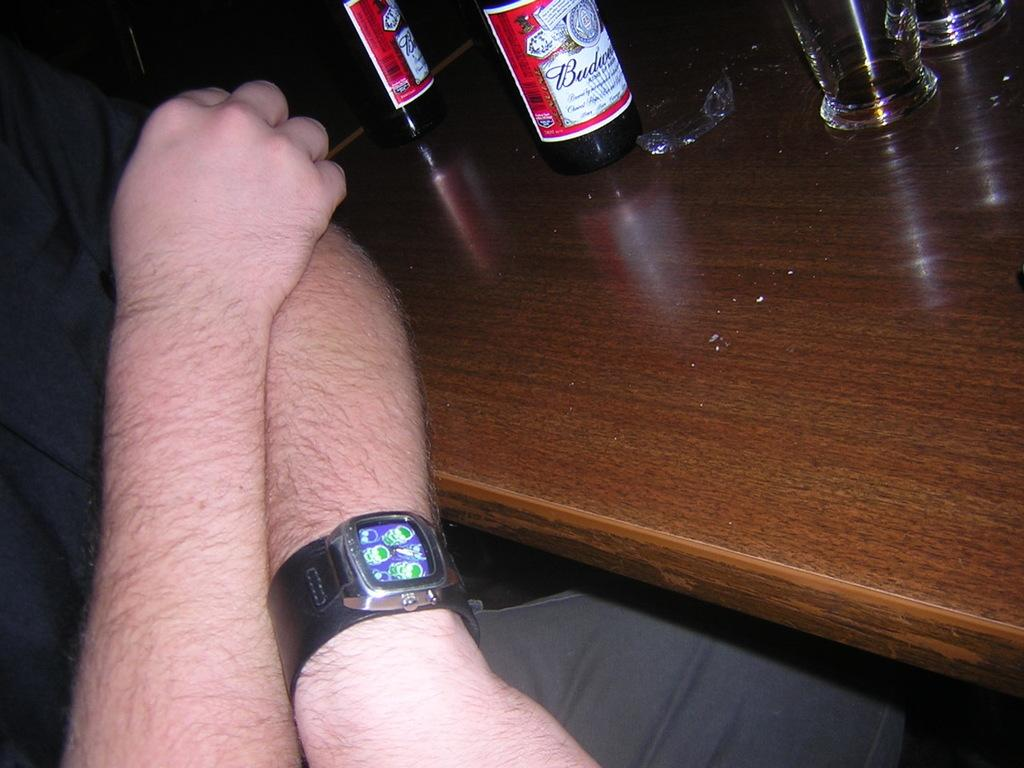<image>
Present a compact description of the photo's key features. Budweiser bottles on a table next to a man with hairy arms 